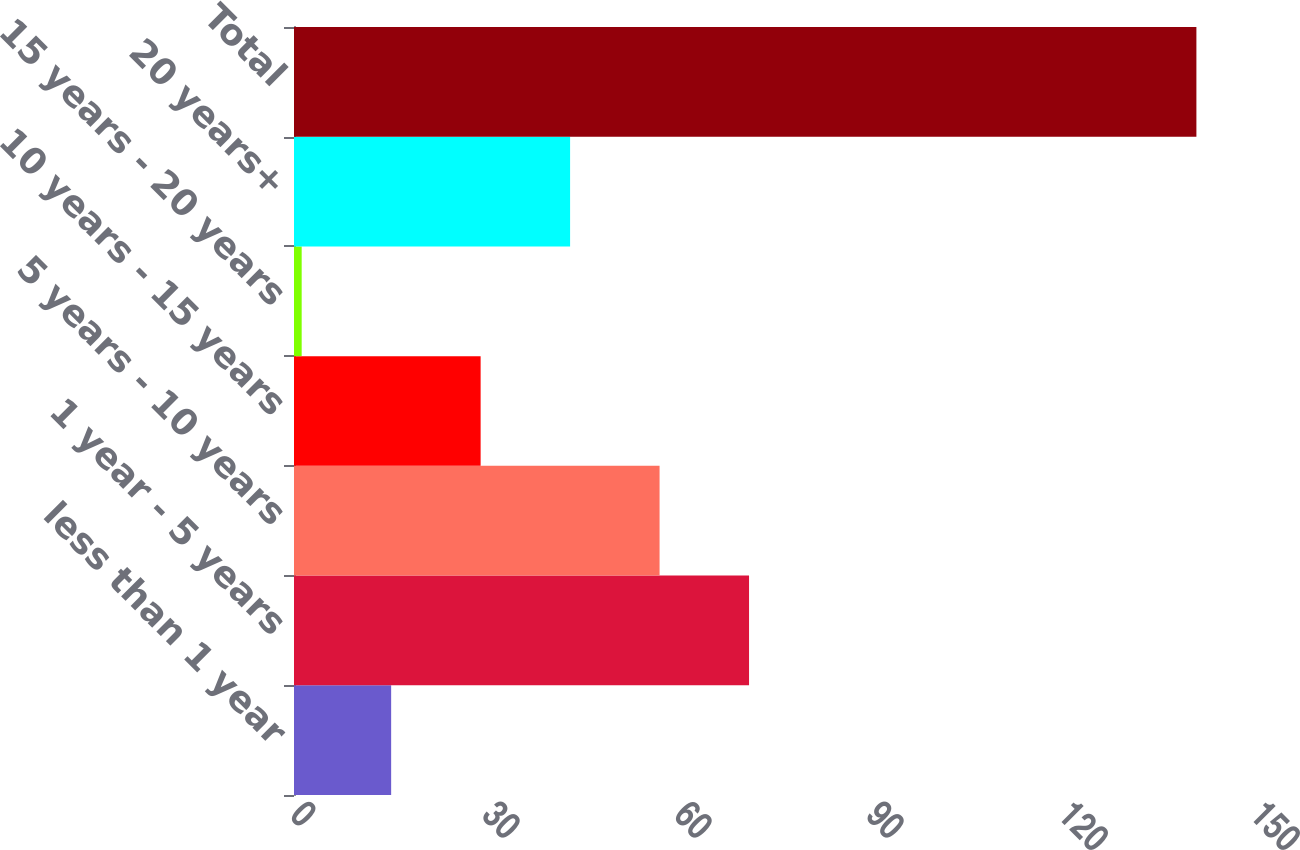<chart> <loc_0><loc_0><loc_500><loc_500><bar_chart><fcel>less than 1 year<fcel>1 year - 5 years<fcel>5 years - 10 years<fcel>10 years - 15 years<fcel>15 years - 20 years<fcel>20 years+<fcel>Total<nl><fcel>15.18<fcel>71.1<fcel>57.12<fcel>29.16<fcel>1.2<fcel>43.14<fcel>141<nl></chart> 